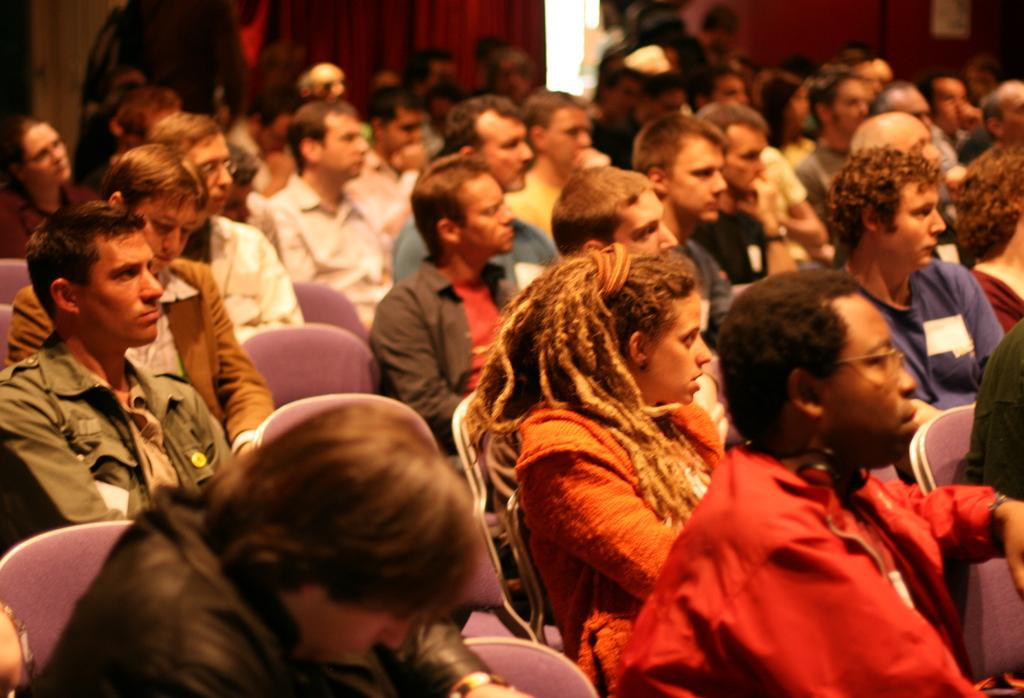What is happening in the image? There is a group of people sitting in the image. Can you describe the appearance of one person in the group? One person in the group is wearing a red dress. What can be seen in the background of the image? There are curtains visible in the background of the image. What is the price of the question being asked by the person in the red dress? There is no question being asked in the image, and therefore no price can be determined. 